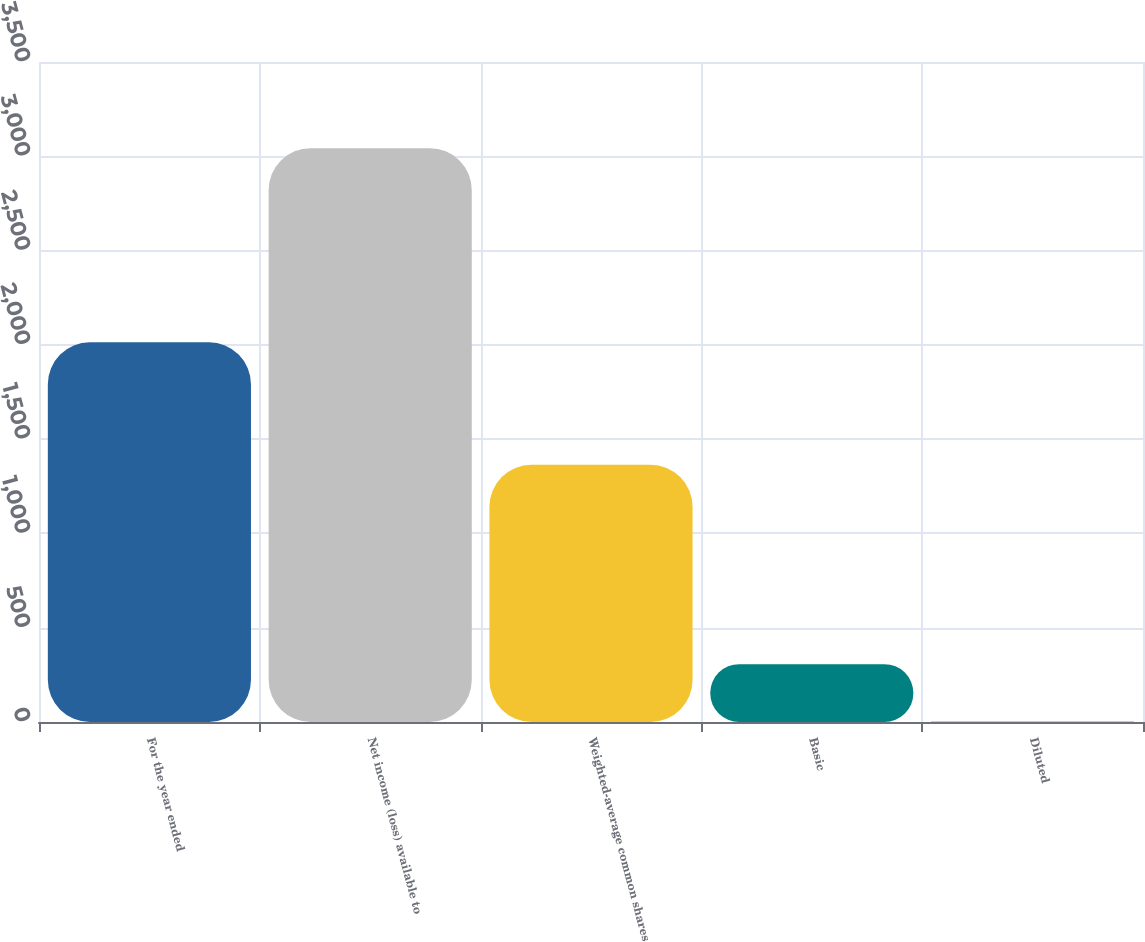Convert chart. <chart><loc_0><loc_0><loc_500><loc_500><bar_chart><fcel>For the year ended<fcel>Net income (loss) available to<fcel>Weighted-average common shares<fcel>Basic<fcel>Diluted<nl><fcel>2014<fcel>3043<fcel>1364.25<fcel>306.79<fcel>2.54<nl></chart> 